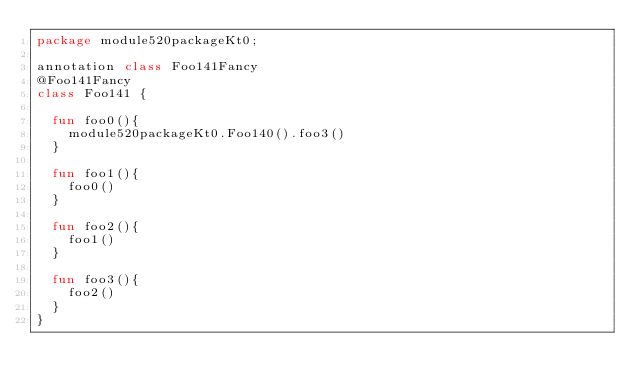Convert code to text. <code><loc_0><loc_0><loc_500><loc_500><_Kotlin_>package module520packageKt0;

annotation class Foo141Fancy
@Foo141Fancy
class Foo141 {

  fun foo0(){
    module520packageKt0.Foo140().foo3()
  }

  fun foo1(){
    foo0()
  }

  fun foo2(){
    foo1()
  }

  fun foo3(){
    foo2()
  }
}</code> 